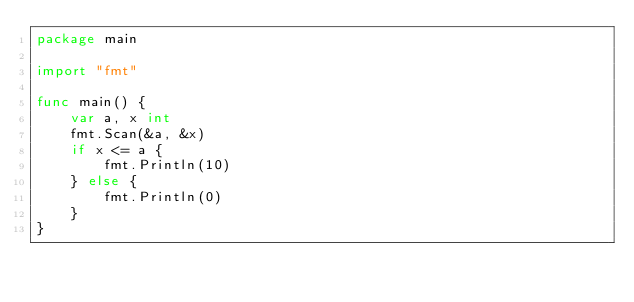<code> <loc_0><loc_0><loc_500><loc_500><_Go_>package main

import "fmt"

func main() {
	var a, x int
	fmt.Scan(&a, &x)
	if x <= a {
		fmt.Println(10)
	} else {
		fmt.Println(0)
	}
}
</code> 